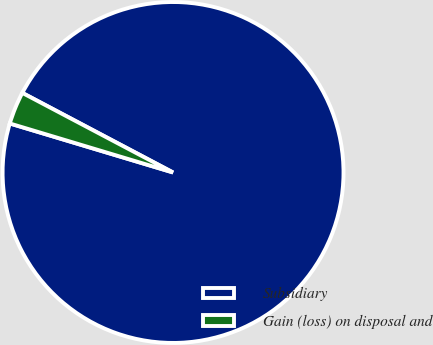Convert chart. <chart><loc_0><loc_0><loc_500><loc_500><pie_chart><fcel>Subsidiary<fcel>Gain (loss) on disposal and<nl><fcel>96.91%<fcel>3.09%<nl></chart> 